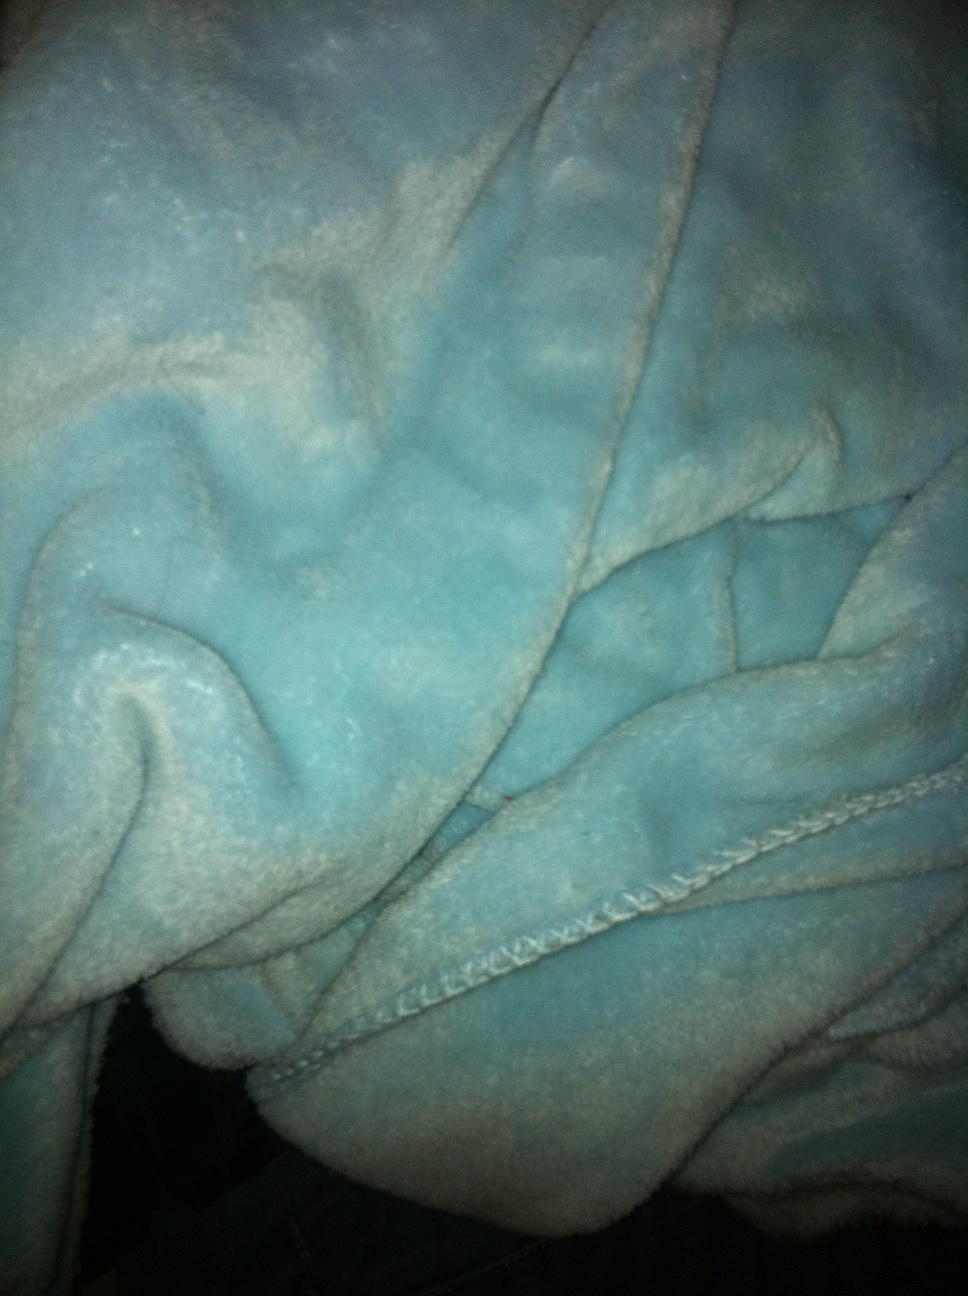This looks like a cozy bathrobe. What setting or occasion might it be used for? This plush bathrobe is perfect for a relaxing day at a spa or during a tranquil evening at home. Its cozy texture and warm fabric make it ideal for wrapping oneself in after a soothing bath or shower, enhancing the feeling of comfort during one's personal pampering sessions. 